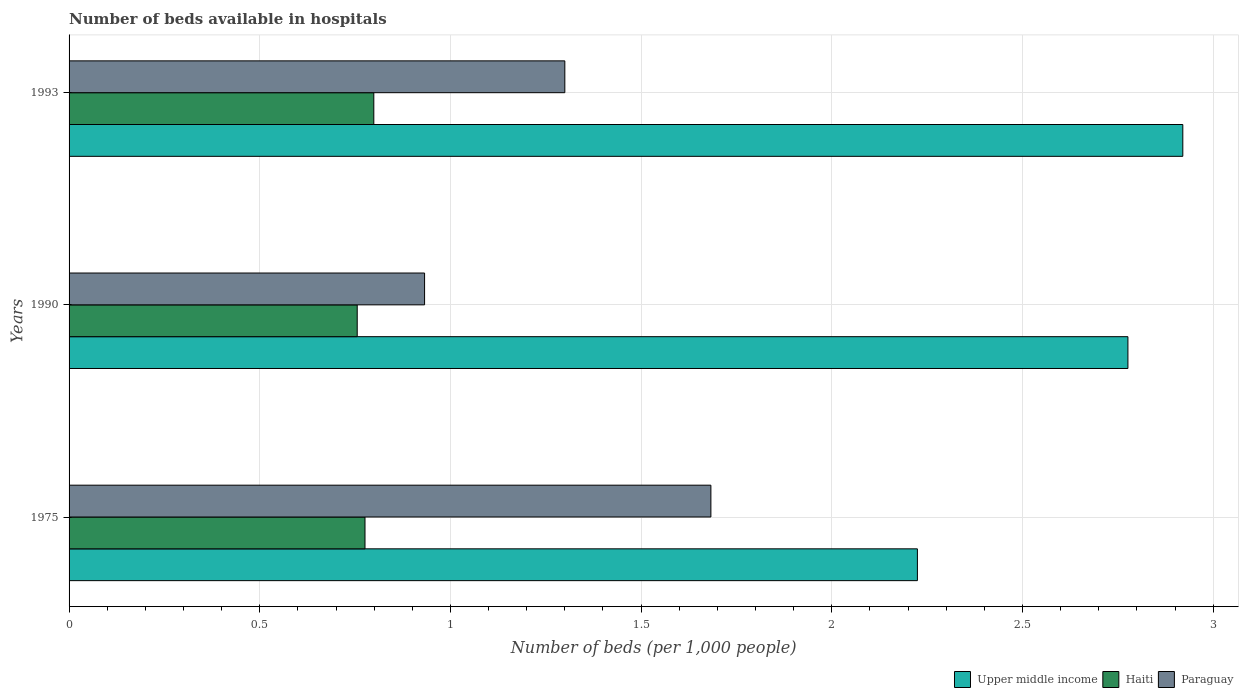How many groups of bars are there?
Provide a succinct answer. 3. In how many cases, is the number of bars for a given year not equal to the number of legend labels?
Provide a succinct answer. 0. What is the number of beds in the hospiatls of in Paraguay in 1990?
Your answer should be very brief. 0.93. Across all years, what is the maximum number of beds in the hospiatls of in Paraguay?
Make the answer very short. 1.68. Across all years, what is the minimum number of beds in the hospiatls of in Upper middle income?
Provide a short and direct response. 2.22. In which year was the number of beds in the hospiatls of in Haiti minimum?
Provide a succinct answer. 1990. What is the total number of beds in the hospiatls of in Upper middle income in the graph?
Provide a succinct answer. 7.92. What is the difference between the number of beds in the hospiatls of in Upper middle income in 1975 and that in 1990?
Provide a succinct answer. -0.55. What is the difference between the number of beds in the hospiatls of in Paraguay in 1990 and the number of beds in the hospiatls of in Upper middle income in 1993?
Your response must be concise. -1.99. What is the average number of beds in the hospiatls of in Upper middle income per year?
Ensure brevity in your answer.  2.64. In the year 1993, what is the difference between the number of beds in the hospiatls of in Paraguay and number of beds in the hospiatls of in Upper middle income?
Your answer should be compact. -1.62. What is the ratio of the number of beds in the hospiatls of in Upper middle income in 1975 to that in 1993?
Ensure brevity in your answer.  0.76. Is the difference between the number of beds in the hospiatls of in Paraguay in 1975 and 1993 greater than the difference between the number of beds in the hospiatls of in Upper middle income in 1975 and 1993?
Keep it short and to the point. Yes. What is the difference between the highest and the second highest number of beds in the hospiatls of in Upper middle income?
Give a very brief answer. 0.14. What is the difference between the highest and the lowest number of beds in the hospiatls of in Upper middle income?
Ensure brevity in your answer.  0.7. Is the sum of the number of beds in the hospiatls of in Haiti in 1975 and 1990 greater than the maximum number of beds in the hospiatls of in Paraguay across all years?
Ensure brevity in your answer.  No. What does the 3rd bar from the top in 1990 represents?
Your answer should be compact. Upper middle income. What does the 2nd bar from the bottom in 1975 represents?
Ensure brevity in your answer.  Haiti. Is it the case that in every year, the sum of the number of beds in the hospiatls of in Haiti and number of beds in the hospiatls of in Upper middle income is greater than the number of beds in the hospiatls of in Paraguay?
Offer a very short reply. Yes. How many bars are there?
Give a very brief answer. 9. Are all the bars in the graph horizontal?
Your answer should be compact. Yes. How many years are there in the graph?
Keep it short and to the point. 3. Does the graph contain any zero values?
Provide a short and direct response. No. How many legend labels are there?
Provide a short and direct response. 3. How are the legend labels stacked?
Your answer should be compact. Horizontal. What is the title of the graph?
Keep it short and to the point. Number of beds available in hospitals. What is the label or title of the X-axis?
Your answer should be compact. Number of beds (per 1,0 people). What is the label or title of the Y-axis?
Ensure brevity in your answer.  Years. What is the Number of beds (per 1,000 people) in Upper middle income in 1975?
Provide a succinct answer. 2.22. What is the Number of beds (per 1,000 people) of Haiti in 1975?
Give a very brief answer. 0.78. What is the Number of beds (per 1,000 people) of Paraguay in 1975?
Keep it short and to the point. 1.68. What is the Number of beds (per 1,000 people) of Upper middle income in 1990?
Give a very brief answer. 2.78. What is the Number of beds (per 1,000 people) of Haiti in 1990?
Keep it short and to the point. 0.76. What is the Number of beds (per 1,000 people) of Paraguay in 1990?
Your answer should be compact. 0.93. What is the Number of beds (per 1,000 people) of Upper middle income in 1993?
Offer a very short reply. 2.92. What is the Number of beds (per 1,000 people) of Haiti in 1993?
Give a very brief answer. 0.8. What is the Number of beds (per 1,000 people) in Paraguay in 1993?
Make the answer very short. 1.3. Across all years, what is the maximum Number of beds (per 1,000 people) of Upper middle income?
Provide a short and direct response. 2.92. Across all years, what is the maximum Number of beds (per 1,000 people) in Haiti?
Give a very brief answer. 0.8. Across all years, what is the maximum Number of beds (per 1,000 people) of Paraguay?
Offer a very short reply. 1.68. Across all years, what is the minimum Number of beds (per 1,000 people) in Upper middle income?
Give a very brief answer. 2.22. Across all years, what is the minimum Number of beds (per 1,000 people) in Haiti?
Keep it short and to the point. 0.76. Across all years, what is the minimum Number of beds (per 1,000 people) in Paraguay?
Keep it short and to the point. 0.93. What is the total Number of beds (per 1,000 people) of Upper middle income in the graph?
Keep it short and to the point. 7.92. What is the total Number of beds (per 1,000 people) of Haiti in the graph?
Provide a short and direct response. 2.33. What is the total Number of beds (per 1,000 people) of Paraguay in the graph?
Provide a succinct answer. 3.92. What is the difference between the Number of beds (per 1,000 people) in Upper middle income in 1975 and that in 1990?
Ensure brevity in your answer.  -0.55. What is the difference between the Number of beds (per 1,000 people) in Haiti in 1975 and that in 1990?
Your answer should be very brief. 0.02. What is the difference between the Number of beds (per 1,000 people) in Paraguay in 1975 and that in 1990?
Your answer should be very brief. 0.75. What is the difference between the Number of beds (per 1,000 people) in Upper middle income in 1975 and that in 1993?
Provide a short and direct response. -0.7. What is the difference between the Number of beds (per 1,000 people) of Haiti in 1975 and that in 1993?
Your response must be concise. -0.02. What is the difference between the Number of beds (per 1,000 people) in Paraguay in 1975 and that in 1993?
Offer a very short reply. 0.38. What is the difference between the Number of beds (per 1,000 people) of Upper middle income in 1990 and that in 1993?
Provide a short and direct response. -0.14. What is the difference between the Number of beds (per 1,000 people) of Haiti in 1990 and that in 1993?
Offer a very short reply. -0.04. What is the difference between the Number of beds (per 1,000 people) in Paraguay in 1990 and that in 1993?
Provide a succinct answer. -0.37. What is the difference between the Number of beds (per 1,000 people) of Upper middle income in 1975 and the Number of beds (per 1,000 people) of Haiti in 1990?
Ensure brevity in your answer.  1.47. What is the difference between the Number of beds (per 1,000 people) in Upper middle income in 1975 and the Number of beds (per 1,000 people) in Paraguay in 1990?
Your response must be concise. 1.29. What is the difference between the Number of beds (per 1,000 people) of Haiti in 1975 and the Number of beds (per 1,000 people) of Paraguay in 1990?
Your answer should be very brief. -0.16. What is the difference between the Number of beds (per 1,000 people) in Upper middle income in 1975 and the Number of beds (per 1,000 people) in Haiti in 1993?
Keep it short and to the point. 1.43. What is the difference between the Number of beds (per 1,000 people) of Upper middle income in 1975 and the Number of beds (per 1,000 people) of Paraguay in 1993?
Make the answer very short. 0.92. What is the difference between the Number of beds (per 1,000 people) in Haiti in 1975 and the Number of beds (per 1,000 people) in Paraguay in 1993?
Keep it short and to the point. -0.52. What is the difference between the Number of beds (per 1,000 people) in Upper middle income in 1990 and the Number of beds (per 1,000 people) in Haiti in 1993?
Offer a very short reply. 1.98. What is the difference between the Number of beds (per 1,000 people) in Upper middle income in 1990 and the Number of beds (per 1,000 people) in Paraguay in 1993?
Provide a succinct answer. 1.48. What is the difference between the Number of beds (per 1,000 people) in Haiti in 1990 and the Number of beds (per 1,000 people) in Paraguay in 1993?
Your answer should be very brief. -0.54. What is the average Number of beds (per 1,000 people) of Upper middle income per year?
Your answer should be compact. 2.64. What is the average Number of beds (per 1,000 people) in Haiti per year?
Offer a very short reply. 0.78. What is the average Number of beds (per 1,000 people) of Paraguay per year?
Give a very brief answer. 1.31. In the year 1975, what is the difference between the Number of beds (per 1,000 people) of Upper middle income and Number of beds (per 1,000 people) of Haiti?
Ensure brevity in your answer.  1.45. In the year 1975, what is the difference between the Number of beds (per 1,000 people) in Upper middle income and Number of beds (per 1,000 people) in Paraguay?
Offer a terse response. 0.54. In the year 1975, what is the difference between the Number of beds (per 1,000 people) in Haiti and Number of beds (per 1,000 people) in Paraguay?
Provide a succinct answer. -0.91. In the year 1990, what is the difference between the Number of beds (per 1,000 people) of Upper middle income and Number of beds (per 1,000 people) of Haiti?
Your answer should be very brief. 2.02. In the year 1990, what is the difference between the Number of beds (per 1,000 people) in Upper middle income and Number of beds (per 1,000 people) in Paraguay?
Make the answer very short. 1.84. In the year 1990, what is the difference between the Number of beds (per 1,000 people) of Haiti and Number of beds (per 1,000 people) of Paraguay?
Provide a succinct answer. -0.18. In the year 1993, what is the difference between the Number of beds (per 1,000 people) in Upper middle income and Number of beds (per 1,000 people) in Haiti?
Ensure brevity in your answer.  2.12. In the year 1993, what is the difference between the Number of beds (per 1,000 people) in Upper middle income and Number of beds (per 1,000 people) in Paraguay?
Keep it short and to the point. 1.62. In the year 1993, what is the difference between the Number of beds (per 1,000 people) of Haiti and Number of beds (per 1,000 people) of Paraguay?
Provide a succinct answer. -0.5. What is the ratio of the Number of beds (per 1,000 people) in Upper middle income in 1975 to that in 1990?
Provide a short and direct response. 0.8. What is the ratio of the Number of beds (per 1,000 people) of Haiti in 1975 to that in 1990?
Make the answer very short. 1.03. What is the ratio of the Number of beds (per 1,000 people) in Paraguay in 1975 to that in 1990?
Keep it short and to the point. 1.81. What is the ratio of the Number of beds (per 1,000 people) of Upper middle income in 1975 to that in 1993?
Your answer should be very brief. 0.76. What is the ratio of the Number of beds (per 1,000 people) in Haiti in 1975 to that in 1993?
Offer a very short reply. 0.97. What is the ratio of the Number of beds (per 1,000 people) in Paraguay in 1975 to that in 1993?
Offer a terse response. 1.29. What is the ratio of the Number of beds (per 1,000 people) in Upper middle income in 1990 to that in 1993?
Your answer should be very brief. 0.95. What is the ratio of the Number of beds (per 1,000 people) in Haiti in 1990 to that in 1993?
Keep it short and to the point. 0.95. What is the ratio of the Number of beds (per 1,000 people) in Paraguay in 1990 to that in 1993?
Provide a succinct answer. 0.72. What is the difference between the highest and the second highest Number of beds (per 1,000 people) in Upper middle income?
Your answer should be very brief. 0.14. What is the difference between the highest and the second highest Number of beds (per 1,000 people) in Haiti?
Your answer should be very brief. 0.02. What is the difference between the highest and the second highest Number of beds (per 1,000 people) in Paraguay?
Your response must be concise. 0.38. What is the difference between the highest and the lowest Number of beds (per 1,000 people) in Upper middle income?
Keep it short and to the point. 0.7. What is the difference between the highest and the lowest Number of beds (per 1,000 people) in Haiti?
Offer a very short reply. 0.04. What is the difference between the highest and the lowest Number of beds (per 1,000 people) in Paraguay?
Provide a succinct answer. 0.75. 